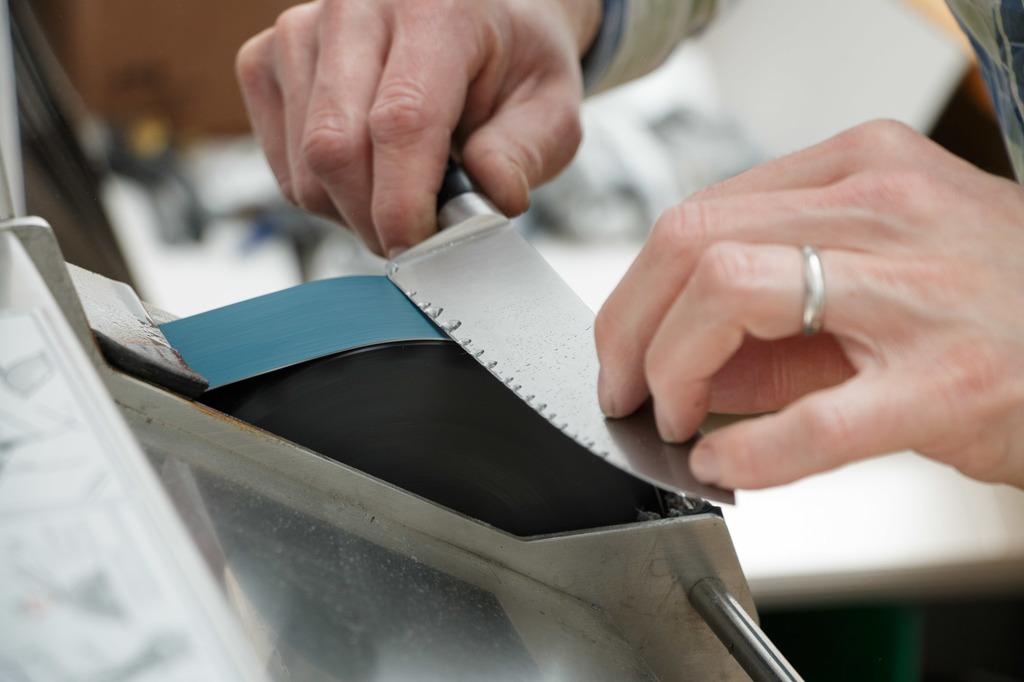What can you describe the main subject in the image? There is a human hand in the image. What is the human hand doing in the image? The human hand is sharpening a knife. What is the plot of the movie that the actor is performing in the image? There is no actor or movie present in the image; it only features a human hand sharpening a knife. How does the image relate to the health of the person in the image? The image does not provide any information about the health of the person; it only shows a hand sharpening a knife. 